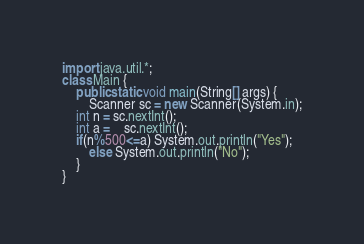Convert code to text. <code><loc_0><loc_0><loc_500><loc_500><_Java_>import java.util.*;
class Main {
    public static void main(String[] args) {
        Scanner sc = new Scanner(System.in);
	int n = sc.nextInt();
	int a =	sc.nextInt();
	if(n%500<=a) System.out.println("Yes");
        else System.out.println("No");
    }
}</code> 